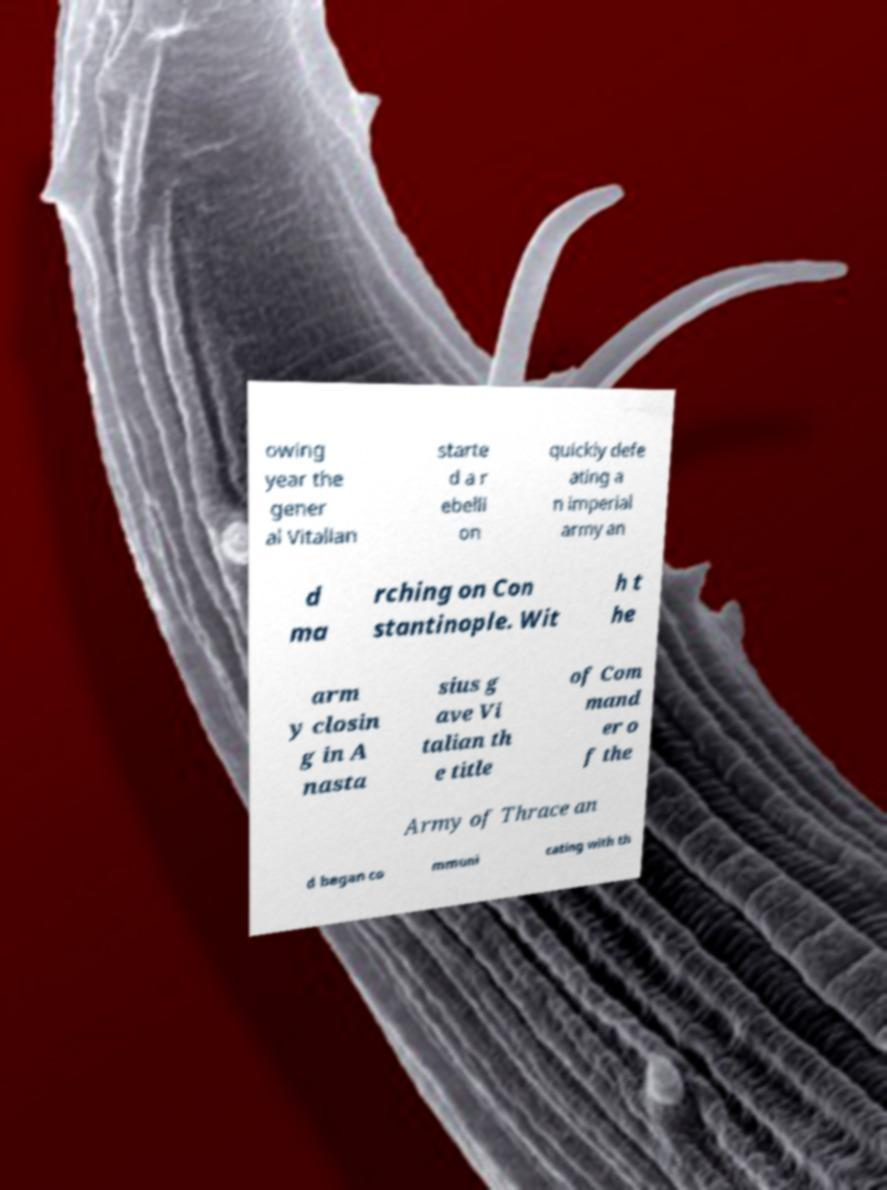Can you accurately transcribe the text from the provided image for me? owing year the gener al Vitalian starte d a r ebelli on quickly defe ating a n imperial army an d ma rching on Con stantinople. Wit h t he arm y closin g in A nasta sius g ave Vi talian th e title of Com mand er o f the Army of Thrace an d began co mmuni cating with th 